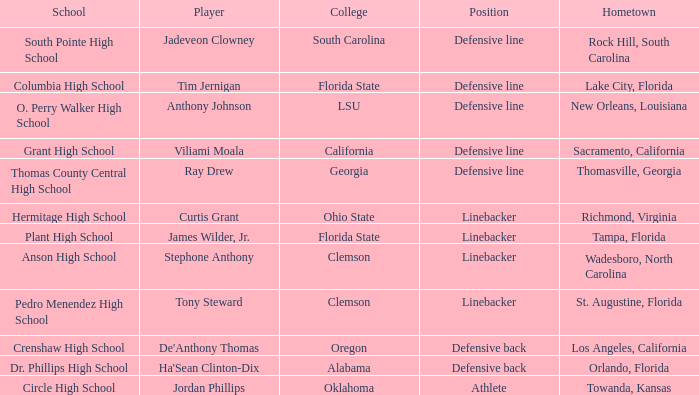From which hometown does a ray drew player come? Thomasville, Georgia. 